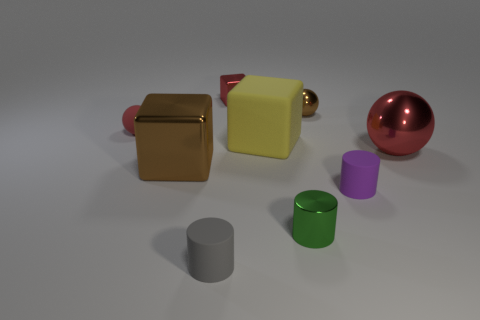Add 1 purple matte cylinders. How many objects exist? 10 Subtract all blocks. How many objects are left? 6 Add 8 tiny shiny balls. How many tiny shiny balls exist? 9 Subtract 1 gray cylinders. How many objects are left? 8 Subtract all matte cubes. Subtract all gray rubber cylinders. How many objects are left? 7 Add 9 big balls. How many big balls are left? 10 